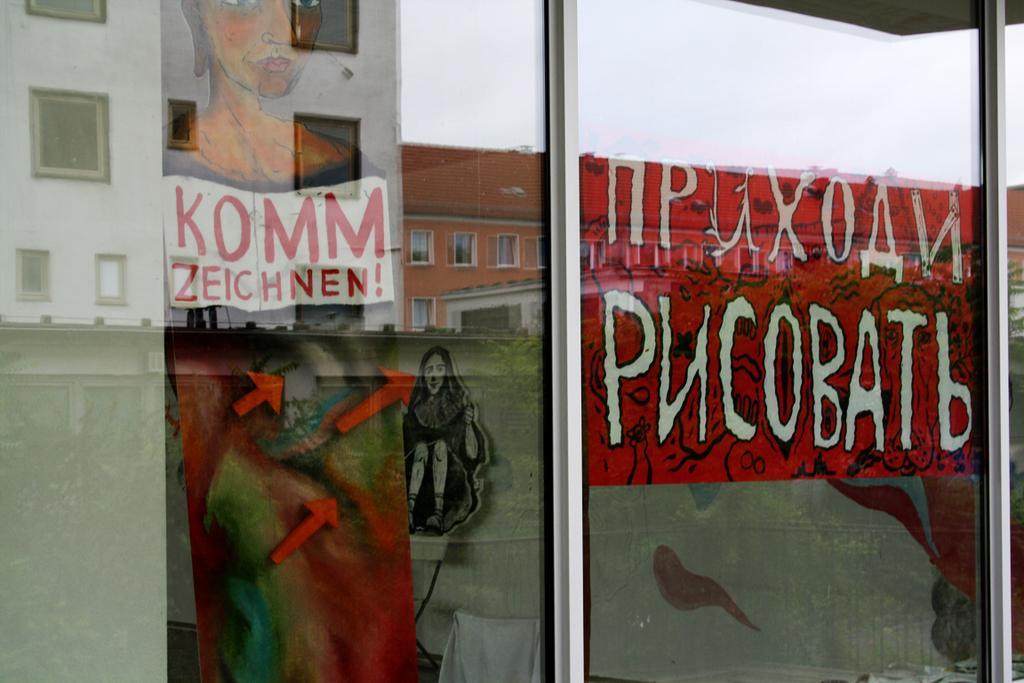Please provide a concise description of this image. In this image, we can see glass doors and there are paintings and some text and through the glass we can see buildings. 